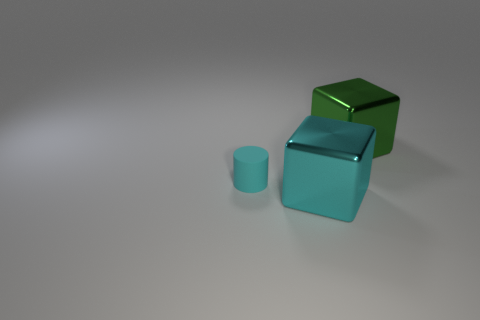Does the green metallic thing have the same shape as the cyan thing that is left of the big cyan object?
Your answer should be compact. No. What is the material of the large block in front of the metal cube behind the cyan metal thing?
Provide a short and direct response. Metal. What number of other objects are the same shape as the small cyan thing?
Make the answer very short. 0. Is the shape of the big metallic object behind the small object the same as the object that is in front of the cyan matte thing?
Your answer should be very brief. Yes. Are there any other things that are made of the same material as the green thing?
Make the answer very short. Yes. What is the large cyan thing made of?
Your answer should be compact. Metal. What material is the large object that is on the right side of the large cyan metallic object?
Make the answer very short. Metal. Are there any other things that have the same color as the small matte cylinder?
Provide a short and direct response. Yes. What is the size of the block that is the same material as the big cyan object?
Provide a succinct answer. Large. How many large objects are either gray metal cylinders or matte cylinders?
Your answer should be compact. 0. 